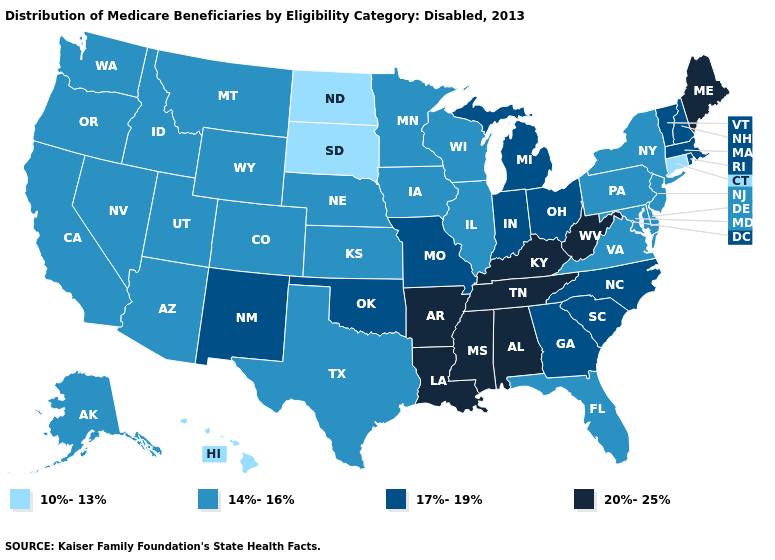What is the value of Iowa?
Be succinct. 14%-16%. Which states hav the highest value in the West?
Concise answer only. New Mexico. What is the value of Wyoming?
Give a very brief answer. 14%-16%. What is the highest value in the USA?
Concise answer only. 20%-25%. What is the value of Indiana?
Short answer required. 17%-19%. What is the lowest value in states that border New York?
Quick response, please. 10%-13%. Which states hav the highest value in the Northeast?
Keep it brief. Maine. Does South Dakota have the highest value in the USA?
Short answer required. No. What is the value of Alabama?
Concise answer only. 20%-25%. What is the lowest value in the Northeast?
Be succinct. 10%-13%. What is the value of Nevada?
Quick response, please. 14%-16%. Name the states that have a value in the range 17%-19%?
Give a very brief answer. Georgia, Indiana, Massachusetts, Michigan, Missouri, New Hampshire, New Mexico, North Carolina, Ohio, Oklahoma, Rhode Island, South Carolina, Vermont. Among the states that border Wyoming , does South Dakota have the highest value?
Write a very short answer. No. Name the states that have a value in the range 20%-25%?
Concise answer only. Alabama, Arkansas, Kentucky, Louisiana, Maine, Mississippi, Tennessee, West Virginia. What is the highest value in the USA?
Write a very short answer. 20%-25%. 